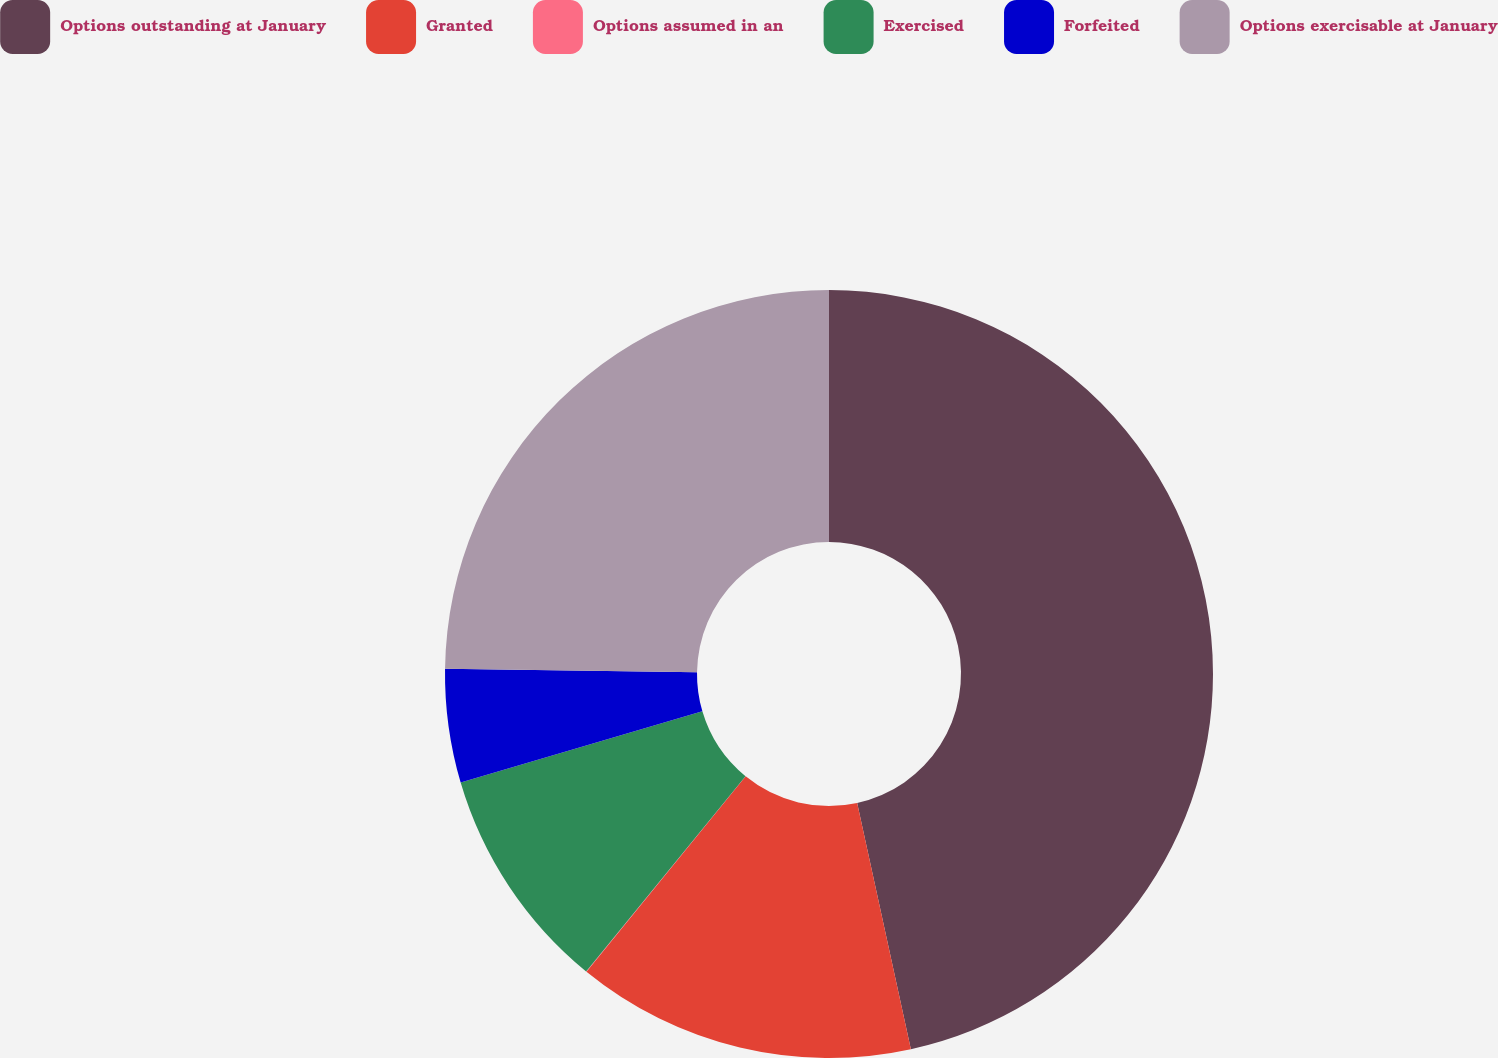Convert chart. <chart><loc_0><loc_0><loc_500><loc_500><pie_chart><fcel>Options outstanding at January<fcel>Granted<fcel>Options assumed in an<fcel>Exercised<fcel>Forfeited<fcel>Options exercisable at January<nl><fcel>46.58%<fcel>14.3%<fcel>0.02%<fcel>9.54%<fcel>4.78%<fcel>24.78%<nl></chart> 